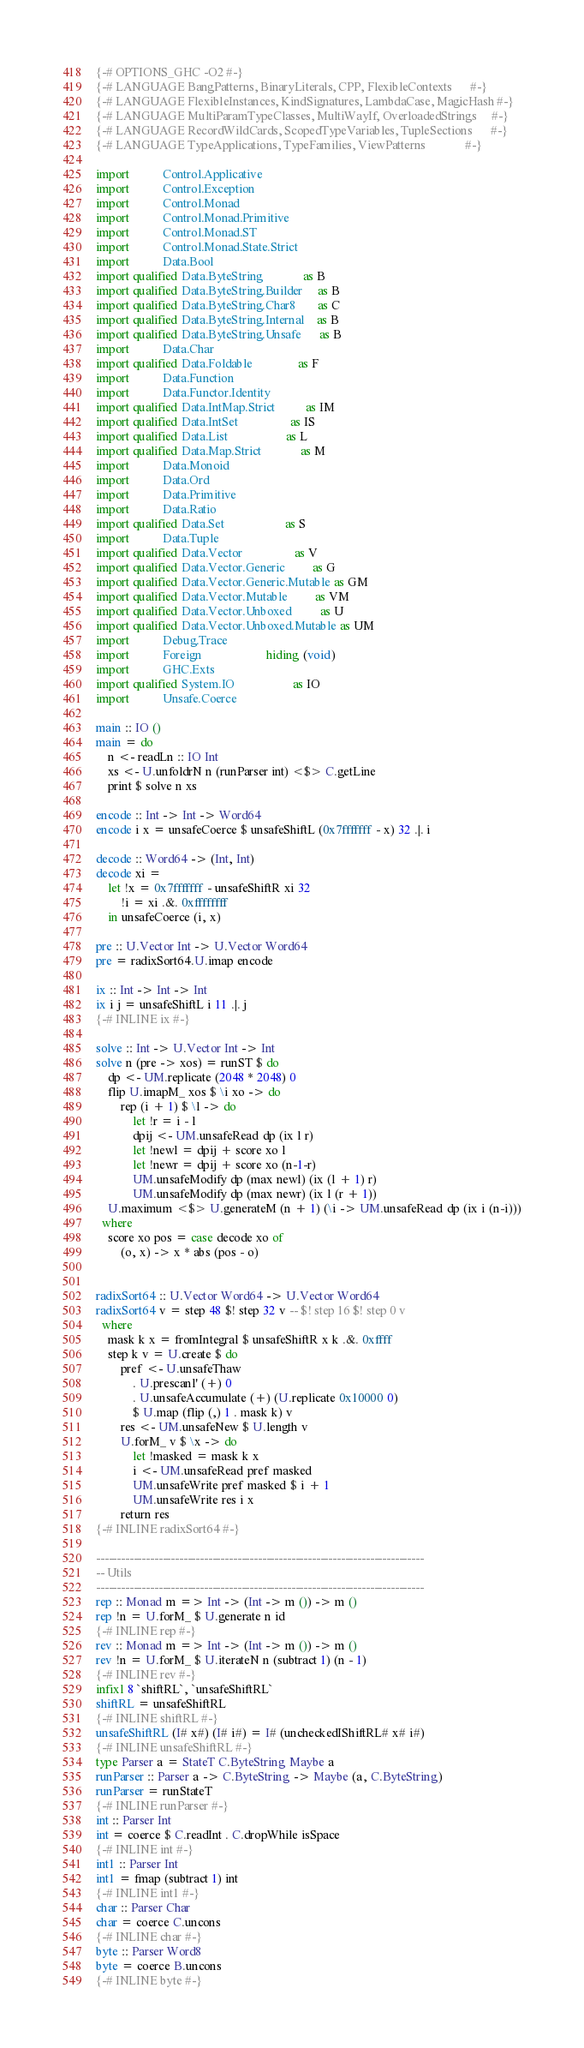<code> <loc_0><loc_0><loc_500><loc_500><_Haskell_>{-# OPTIONS_GHC -O2 #-}
{-# LANGUAGE BangPatterns, BinaryLiterals, CPP, FlexibleContexts      #-}
{-# LANGUAGE FlexibleInstances, KindSignatures, LambdaCase, MagicHash #-}
{-# LANGUAGE MultiParamTypeClasses, MultiWayIf, OverloadedStrings     #-}
{-# LANGUAGE RecordWildCards, ScopedTypeVariables, TupleSections      #-}
{-# LANGUAGE TypeApplications, TypeFamilies, ViewPatterns             #-}

import           Control.Applicative
import           Control.Exception
import           Control.Monad
import           Control.Monad.Primitive
import           Control.Monad.ST
import           Control.Monad.State.Strict
import           Data.Bool
import qualified Data.ByteString             as B
import qualified Data.ByteString.Builder     as B
import qualified Data.ByteString.Char8       as C
import qualified Data.ByteString.Internal    as B
import qualified Data.ByteString.Unsafe      as B
import           Data.Char
import qualified Data.Foldable               as F
import           Data.Function
import           Data.Functor.Identity
import qualified Data.IntMap.Strict          as IM
import qualified Data.IntSet                 as IS
import qualified Data.List                   as L
import qualified Data.Map.Strict             as M
import           Data.Monoid
import           Data.Ord
import           Data.Primitive
import           Data.Ratio
import qualified Data.Set                    as S
import           Data.Tuple
import qualified Data.Vector                 as V
import qualified Data.Vector.Generic         as G
import qualified Data.Vector.Generic.Mutable as GM
import qualified Data.Vector.Mutable         as VM
import qualified Data.Vector.Unboxed         as U
import qualified Data.Vector.Unboxed.Mutable as UM
import           Debug.Trace
import           Foreign                     hiding (void)
import           GHC.Exts
import qualified System.IO                   as IO
import           Unsafe.Coerce

main :: IO ()
main = do
    n <- readLn :: IO Int
    xs <- U.unfoldrN n (runParser int) <$> C.getLine
    print $ solve n xs

encode :: Int -> Int -> Word64
encode i x = unsafeCoerce $ unsafeShiftL (0x7fffffff - x) 32 .|. i

decode :: Word64 -> (Int, Int)
decode xi =
    let !x = 0x7fffffff - unsafeShiftR xi 32
        !i = xi .&. 0xffffffff
    in unsafeCoerce (i, x)

pre :: U.Vector Int -> U.Vector Word64
pre = radixSort64.U.imap encode

ix :: Int -> Int -> Int
ix i j = unsafeShiftL i 11 .|. j
{-# INLINE ix #-}

solve :: Int -> U.Vector Int -> Int
solve n (pre -> xos) = runST $ do
    dp <- UM.replicate (2048 * 2048) 0
    flip U.imapM_ xos $ \i xo -> do
        rep (i + 1) $ \l -> do
            let !r = i - l
            dpij <- UM.unsafeRead dp (ix l r)
            let !newl = dpij + score xo l
            let !newr = dpij + score xo (n-1-r)
            UM.unsafeModify dp (max newl) (ix (l + 1) r)
            UM.unsafeModify dp (max newr) (ix l (r + 1))
    U.maximum <$> U.generateM (n + 1) (\i -> UM.unsafeRead dp (ix i (n-i)))
  where
    score xo pos = case decode xo of
        (o, x) -> x * abs (pos - o)


radixSort64 :: U.Vector Word64 -> U.Vector Word64
radixSort64 v = step 48 $! step 32 v -- $! step 16 $! step 0 v
  where
    mask k x = fromIntegral $ unsafeShiftR x k .&. 0xffff
    step k v = U.create $ do
        pref <- U.unsafeThaw
            . U.prescanl' (+) 0
            . U.unsafeAccumulate (+) (U.replicate 0x10000 0)
            $ U.map (flip (,) 1 . mask k) v
        res <- UM.unsafeNew $ U.length v
        U.forM_ v $ \x -> do
            let !masked = mask k x
            i <- UM.unsafeRead pref masked
            UM.unsafeWrite pref masked $ i + 1
            UM.unsafeWrite res i x
        return res
{-# INLINE radixSort64 #-}

-------------------------------------------------------------------------------
-- Utils
-------------------------------------------------------------------------------
rep :: Monad m => Int -> (Int -> m ()) -> m ()
rep !n = U.forM_ $ U.generate n id
{-# INLINE rep #-}
rev :: Monad m => Int -> (Int -> m ()) -> m ()
rev !n = U.forM_ $ U.iterateN n (subtract 1) (n - 1)
{-# INLINE rev #-}
infixl 8 `shiftRL`, `unsafeShiftRL`
shiftRL = unsafeShiftRL
{-# INLINE shiftRL #-}
unsafeShiftRL (I# x#) (I# i#) = I# (uncheckedIShiftRL# x# i#)
{-# INLINE unsafeShiftRL #-}
type Parser a = StateT C.ByteString Maybe a
runParser :: Parser a -> C.ByteString -> Maybe (a, C.ByteString)
runParser = runStateT
{-# INLINE runParser #-}
int :: Parser Int
int = coerce $ C.readInt . C.dropWhile isSpace
{-# INLINE int #-}
int1 :: Parser Int
int1 = fmap (subtract 1) int
{-# INLINE int1 #-}
char :: Parser Char
char = coerce C.uncons
{-# INLINE char #-}
byte :: Parser Word8
byte = coerce B.uncons
{-# INLINE byte #-}
</code> 